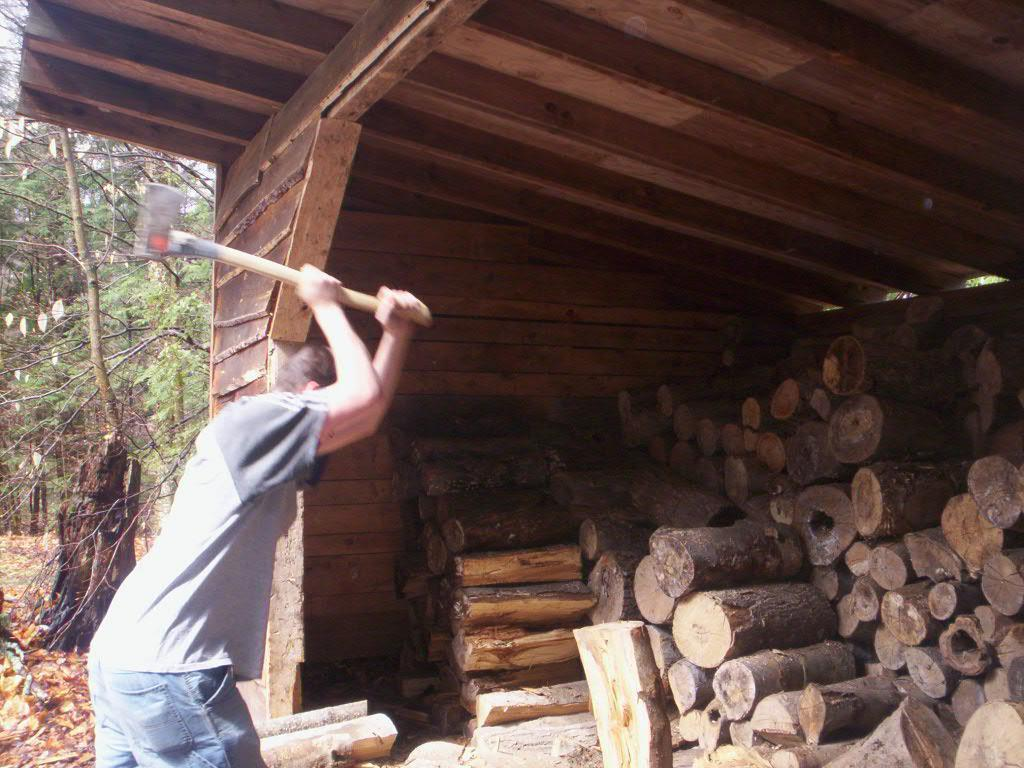What is the man in the image doing? The man is standing and hitting a piece of wood with an ax. What is the man holding in the image? The man is holding an ax in the image. Where is the action taking place? The action is taking place under a wooden shed. What can be seen in the background of the image? Trees and dried leaves on a path are visible in the background. What type of country music is playing in the background of the image? There is no music or indication of any audio in the image, so it cannot be determined what type of country music might be playing. 